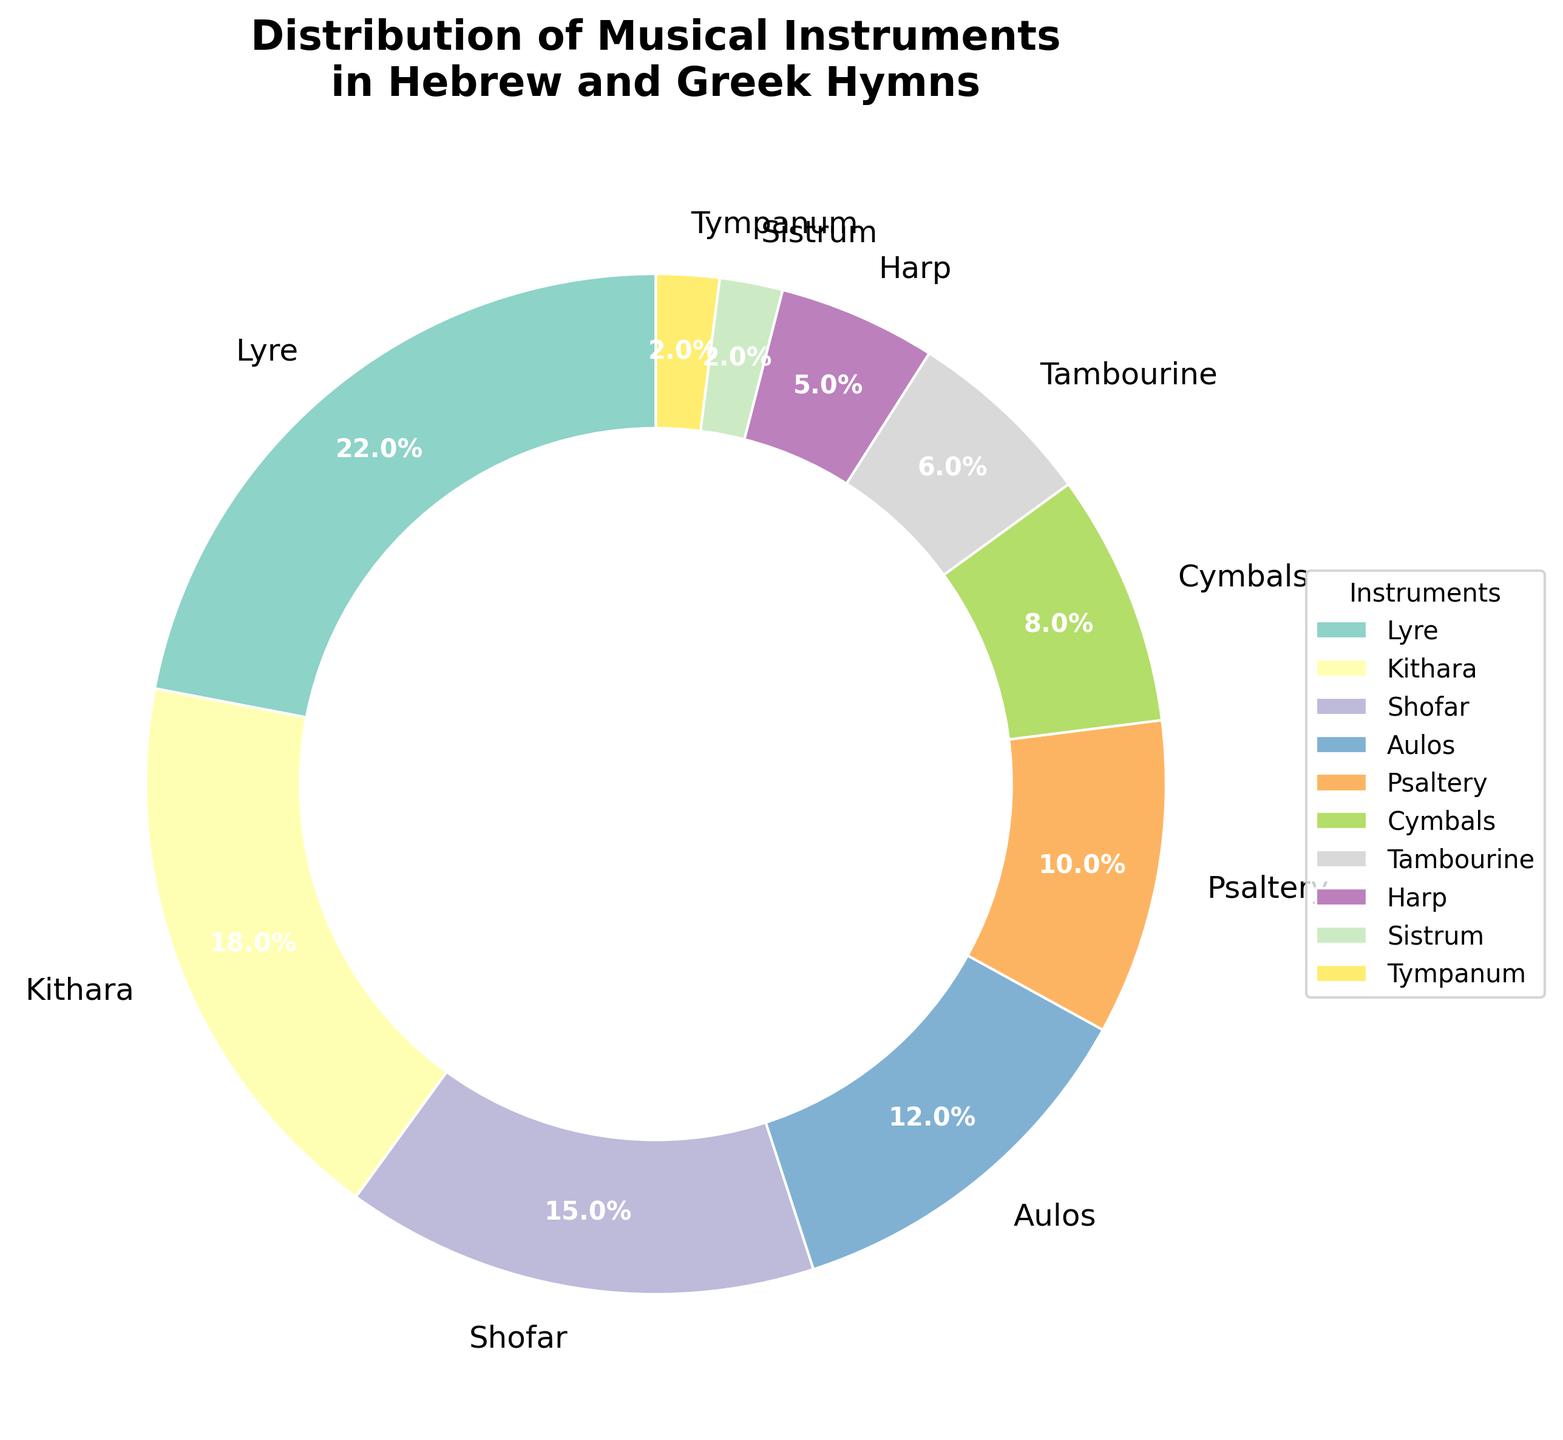What's the most frequently used instrument for accompanying Hebrew and Greek hymns? The largest slice of the pie chart represents the instrument with the highest percentage. The Lyre slice accounts for 22%, which is the largest portion.
Answer: Lyre Which instruments together represent exactly one-third of the total usage? To find one-third of the usage, calculate 33.33% of the total. The Aulos (12%), Psaltery (10%), and Cymbals (8%) together total 30%. While not exactly one-third, they come closest without exceeding or including a larger group.
Answer: Aulos, Psaltery, Cymbals Compare the usage percentages of Lyre and Kithara. How much more is Lyre used compared to Kithara? The Lyre has a percentage of 22%, and the Kithara has 18%. The difference is 22% - 18% = 4%.
Answer: 4% What's the combined percentage of instruments with less than 10% usage? Adding the percentages of the instruments with less than 10% is 8% (Cymbals) + 6% (Tambourine) + 5% (Harp) + 2% (Sistrum) + 2% (Tympanum) = 23%.
Answer: 23% Which instrument represents the smallest slice of the pie chart? The smallest slice corresponds to the instruments with the lowest percentage, which are the Tympanum and Sistrum each representing 2%.
Answer: Tympanum and Sistrum If "Others" are added with a total of 2% usage, will Sistrum still be the least used instrument? Adding an "Others" category at 2% does not change the fact that Sistrum along with Tympanum are already at 2%, meaning they remain the smallest category.
Answer: Yes What percentage of the usage do the top three instruments contribute? Summing up the percentages of the top three instruments: Lyre (22%), Kithara (18%), and Shofar (15%) totals to 22% + 18% + 15% = 55%.
Answer: 55% Which instruments have a percentage that is less than the average percentage usage? The average usage is calculated by totaling all percentages (100) and dividing by the number of instruments (10), so the average is 10%. The instruments below this average are Cymbals (8%), Tambourine (6%), Harp (5%), Sistrum (2%), and Tympanum (2%).
Answer: Cymbals, Tambourine, Harp, Sistrum, Tympanum Which instrument's slice is closest in size to the Shofar's slice? The Shofar represents 15%, and comparing this percentage visually, the Aulos with 12% is the closest in size.
Answer: Aulos What is the difference in usage percentage between the most and least used instrument? The most used instrument is the Lyre at 22%, and the least are Tympanum and Sistrum each at 2%. The difference is 22% - 2% = 20%.
Answer: 20% 